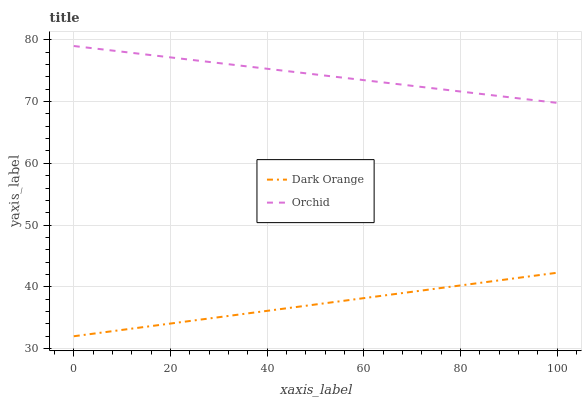Does Dark Orange have the minimum area under the curve?
Answer yes or no. Yes. Does Orchid have the maximum area under the curve?
Answer yes or no. Yes. Does Orchid have the minimum area under the curve?
Answer yes or no. No. Is Dark Orange the smoothest?
Answer yes or no. Yes. Is Orchid the roughest?
Answer yes or no. Yes. Is Orchid the smoothest?
Answer yes or no. No. Does Dark Orange have the lowest value?
Answer yes or no. Yes. Does Orchid have the lowest value?
Answer yes or no. No. Does Orchid have the highest value?
Answer yes or no. Yes. Is Dark Orange less than Orchid?
Answer yes or no. Yes. Is Orchid greater than Dark Orange?
Answer yes or no. Yes. Does Dark Orange intersect Orchid?
Answer yes or no. No. 